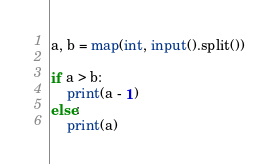<code> <loc_0><loc_0><loc_500><loc_500><_Python_>a, b = map(int, input().split())

if a > b:
    print(a - 1)
else:
    print(a)</code> 